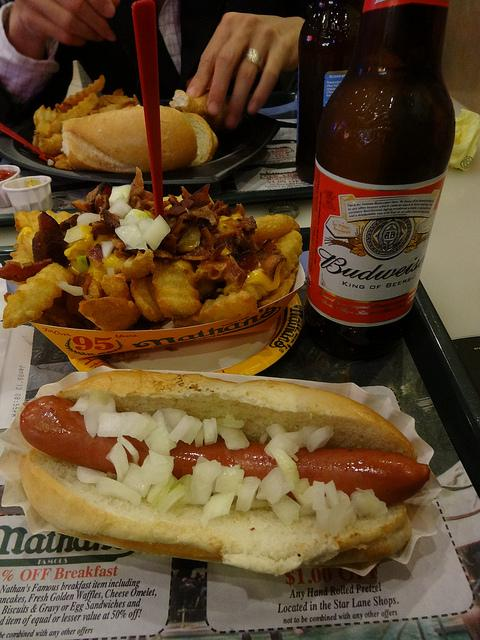Consuming which one of these items will make it dangerous to drive? beer 